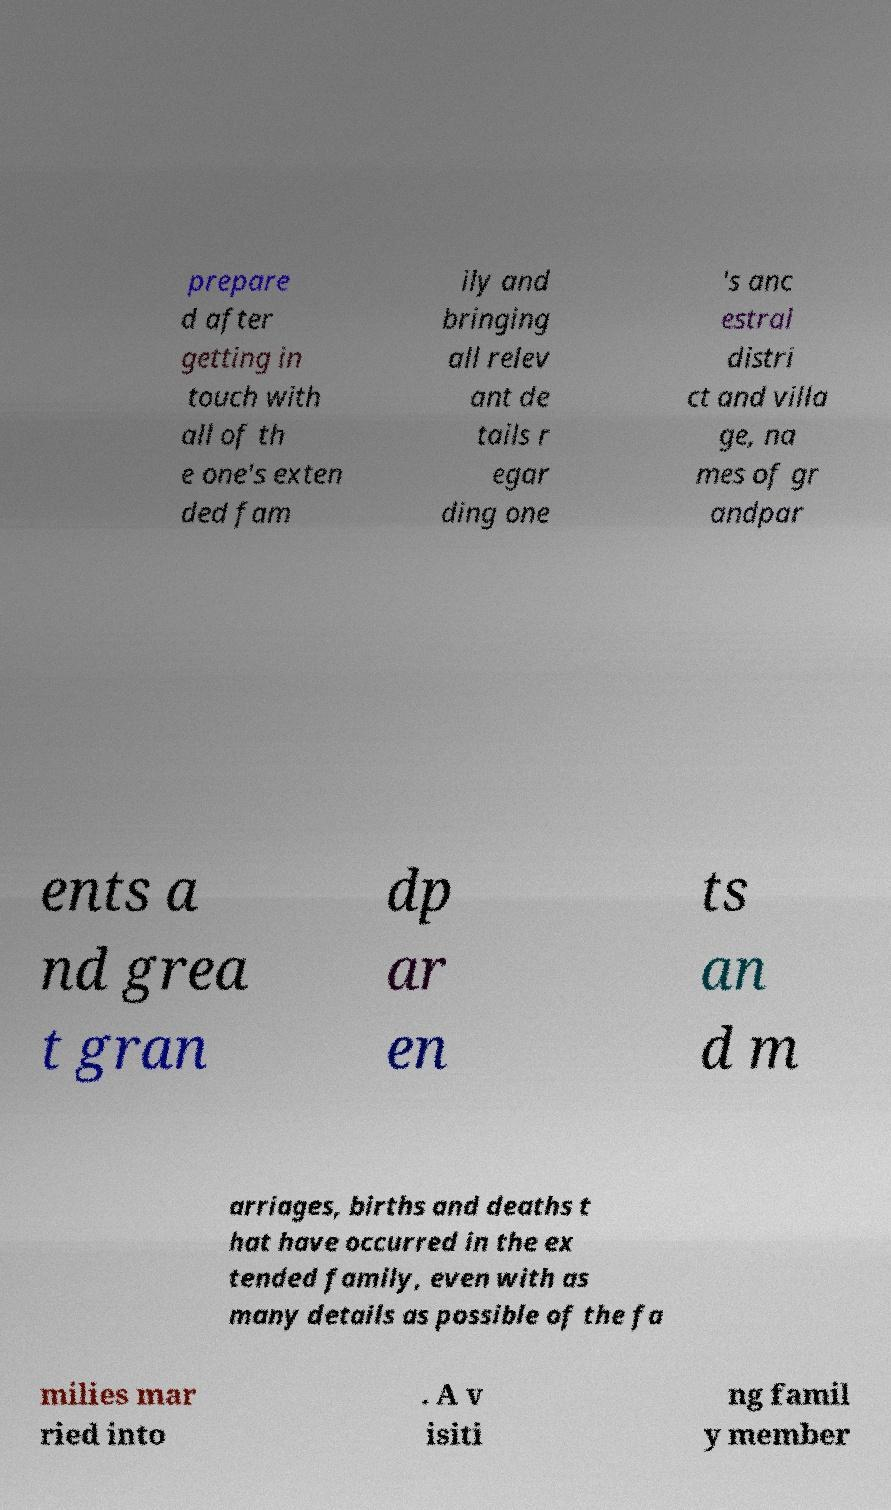For documentation purposes, I need the text within this image transcribed. Could you provide that? prepare d after getting in touch with all of th e one's exten ded fam ily and bringing all relev ant de tails r egar ding one 's anc estral distri ct and villa ge, na mes of gr andpar ents a nd grea t gran dp ar en ts an d m arriages, births and deaths t hat have occurred in the ex tended family, even with as many details as possible of the fa milies mar ried into . A v isiti ng famil y member 